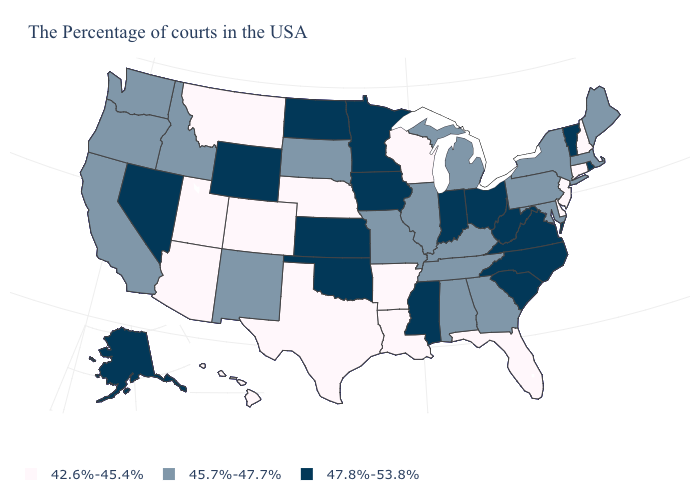Name the states that have a value in the range 47.8%-53.8%?
Write a very short answer. Rhode Island, Vermont, Virginia, North Carolina, South Carolina, West Virginia, Ohio, Indiana, Mississippi, Minnesota, Iowa, Kansas, Oklahoma, North Dakota, Wyoming, Nevada, Alaska. What is the value of Vermont?
Keep it brief. 47.8%-53.8%. Does Delaware have the same value as Alabama?
Give a very brief answer. No. What is the value of Pennsylvania?
Write a very short answer. 45.7%-47.7%. What is the lowest value in the USA?
Give a very brief answer. 42.6%-45.4%. What is the value of Maryland?
Quick response, please. 45.7%-47.7%. What is the lowest value in states that border New Jersey?
Write a very short answer. 42.6%-45.4%. What is the highest value in the USA?
Quick response, please. 47.8%-53.8%. What is the value of Iowa?
Be succinct. 47.8%-53.8%. Does the map have missing data?
Short answer required. No. What is the value of Delaware?
Answer briefly. 42.6%-45.4%. Does Utah have the highest value in the West?
Be succinct. No. Does the map have missing data?
Concise answer only. No. What is the value of North Carolina?
Write a very short answer. 47.8%-53.8%. Is the legend a continuous bar?
Keep it brief. No. 